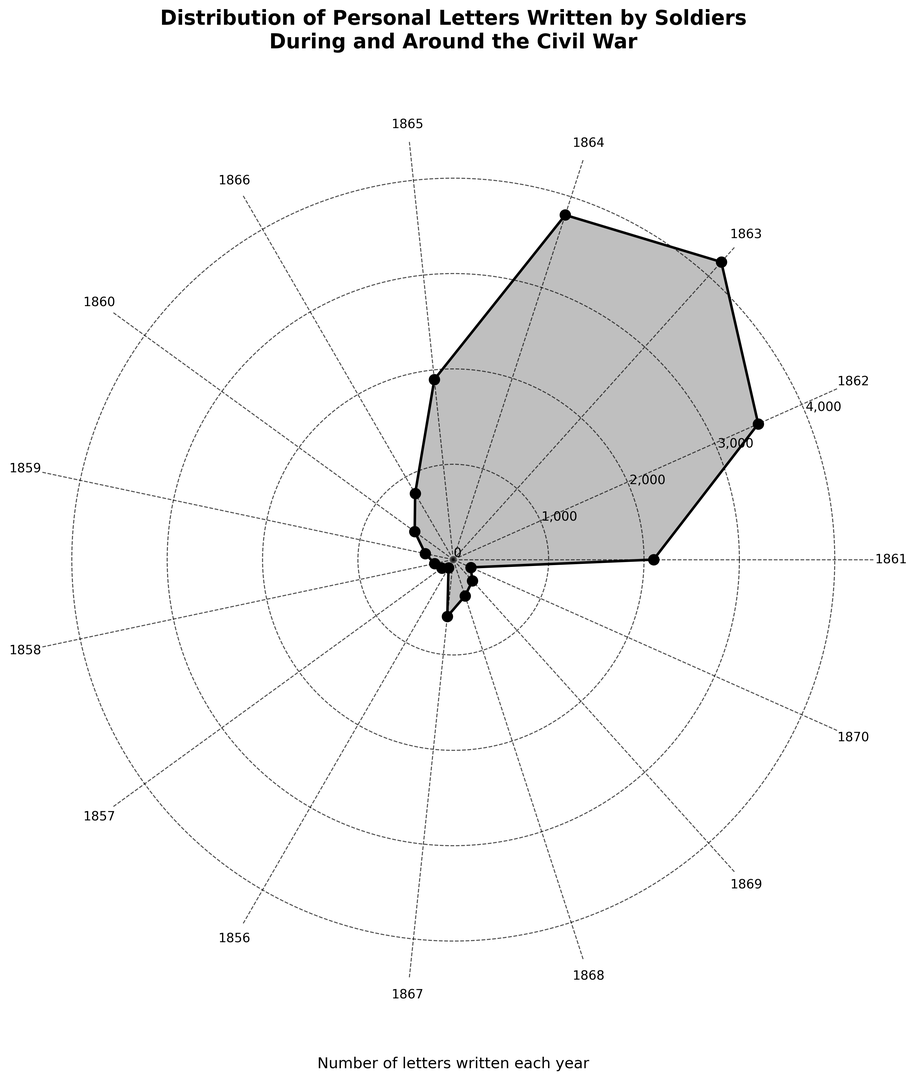What's the highest number of letters written in a year during the Civil War? Look for the highest point on the chart specifically within the years 1861 to 1865, as these are the years of the Civil War. The year 1863 has the highest number with 4200 letters.
Answer: 4200 How does the number of letters in 1865 compare to 1862? Observe the length of the lines representing 1865 and 1862. The number in 1865 (1900 letters) is less than that in 1862 (3500 letters).
Answer: 1865 has fewer letters Which year had the least number of letters written, and how many were written? Identify the smallest data point on the chart. The smallest point is in 1856 with 100 letters.
Answer: 1856, 100 What is the combined number of letters written in 1862 and 1864? Sum the values for 1862 (3500 letters) and 1864 (3800 letters). (3500 + 3800)
Answer: 7300 Compare the number of letters written before the Civil War (1860 and earlier) to the year 1863. How do they measure up? Add up the letters from 1860 and earlier: 1550 (sum of 500, 300, 200, 150, 100). Compare this to 4200 in 1863. 4200 - 1550 = 2650 more letters in 1863.
Answer: 1863 had 2650 more letters What years saw a decrease in the number of letters written compared to the previous year? Check each year's letters against the previous year’s. Decreases are seen from 1864 to 1865 (3800 to 1900) and 1865 to 1866 (1900 to 800).
Answer: 1865, 1866 